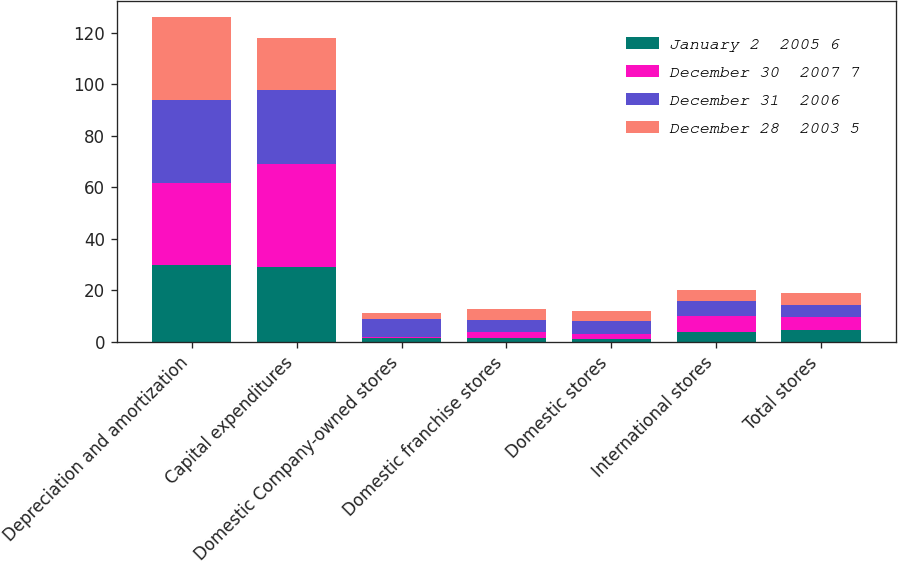<chart> <loc_0><loc_0><loc_500><loc_500><stacked_bar_chart><ecel><fcel>Depreciation and amortization<fcel>Capital expenditures<fcel>Domestic Company-owned stores<fcel>Domestic franchise stores<fcel>Domestic stores<fcel>International stores<fcel>Total stores<nl><fcel>January 2  2005 6<fcel>29.8<fcel>29.2<fcel>1.7<fcel>1.7<fcel>1.3<fcel>4<fcel>4.75<nl><fcel>December 30  2007 7<fcel>31.7<fcel>39.8<fcel>0.1<fcel>2.1<fcel>1.8<fcel>5.9<fcel>4.75<nl><fcel>December 31  2006<fcel>32.4<fcel>28.7<fcel>7.1<fcel>4.6<fcel>4.9<fcel>6.1<fcel>4.75<nl><fcel>December 28  2003 5<fcel>32.3<fcel>20.2<fcel>2.2<fcel>4.4<fcel>4.1<fcel>4<fcel>4.75<nl></chart> 